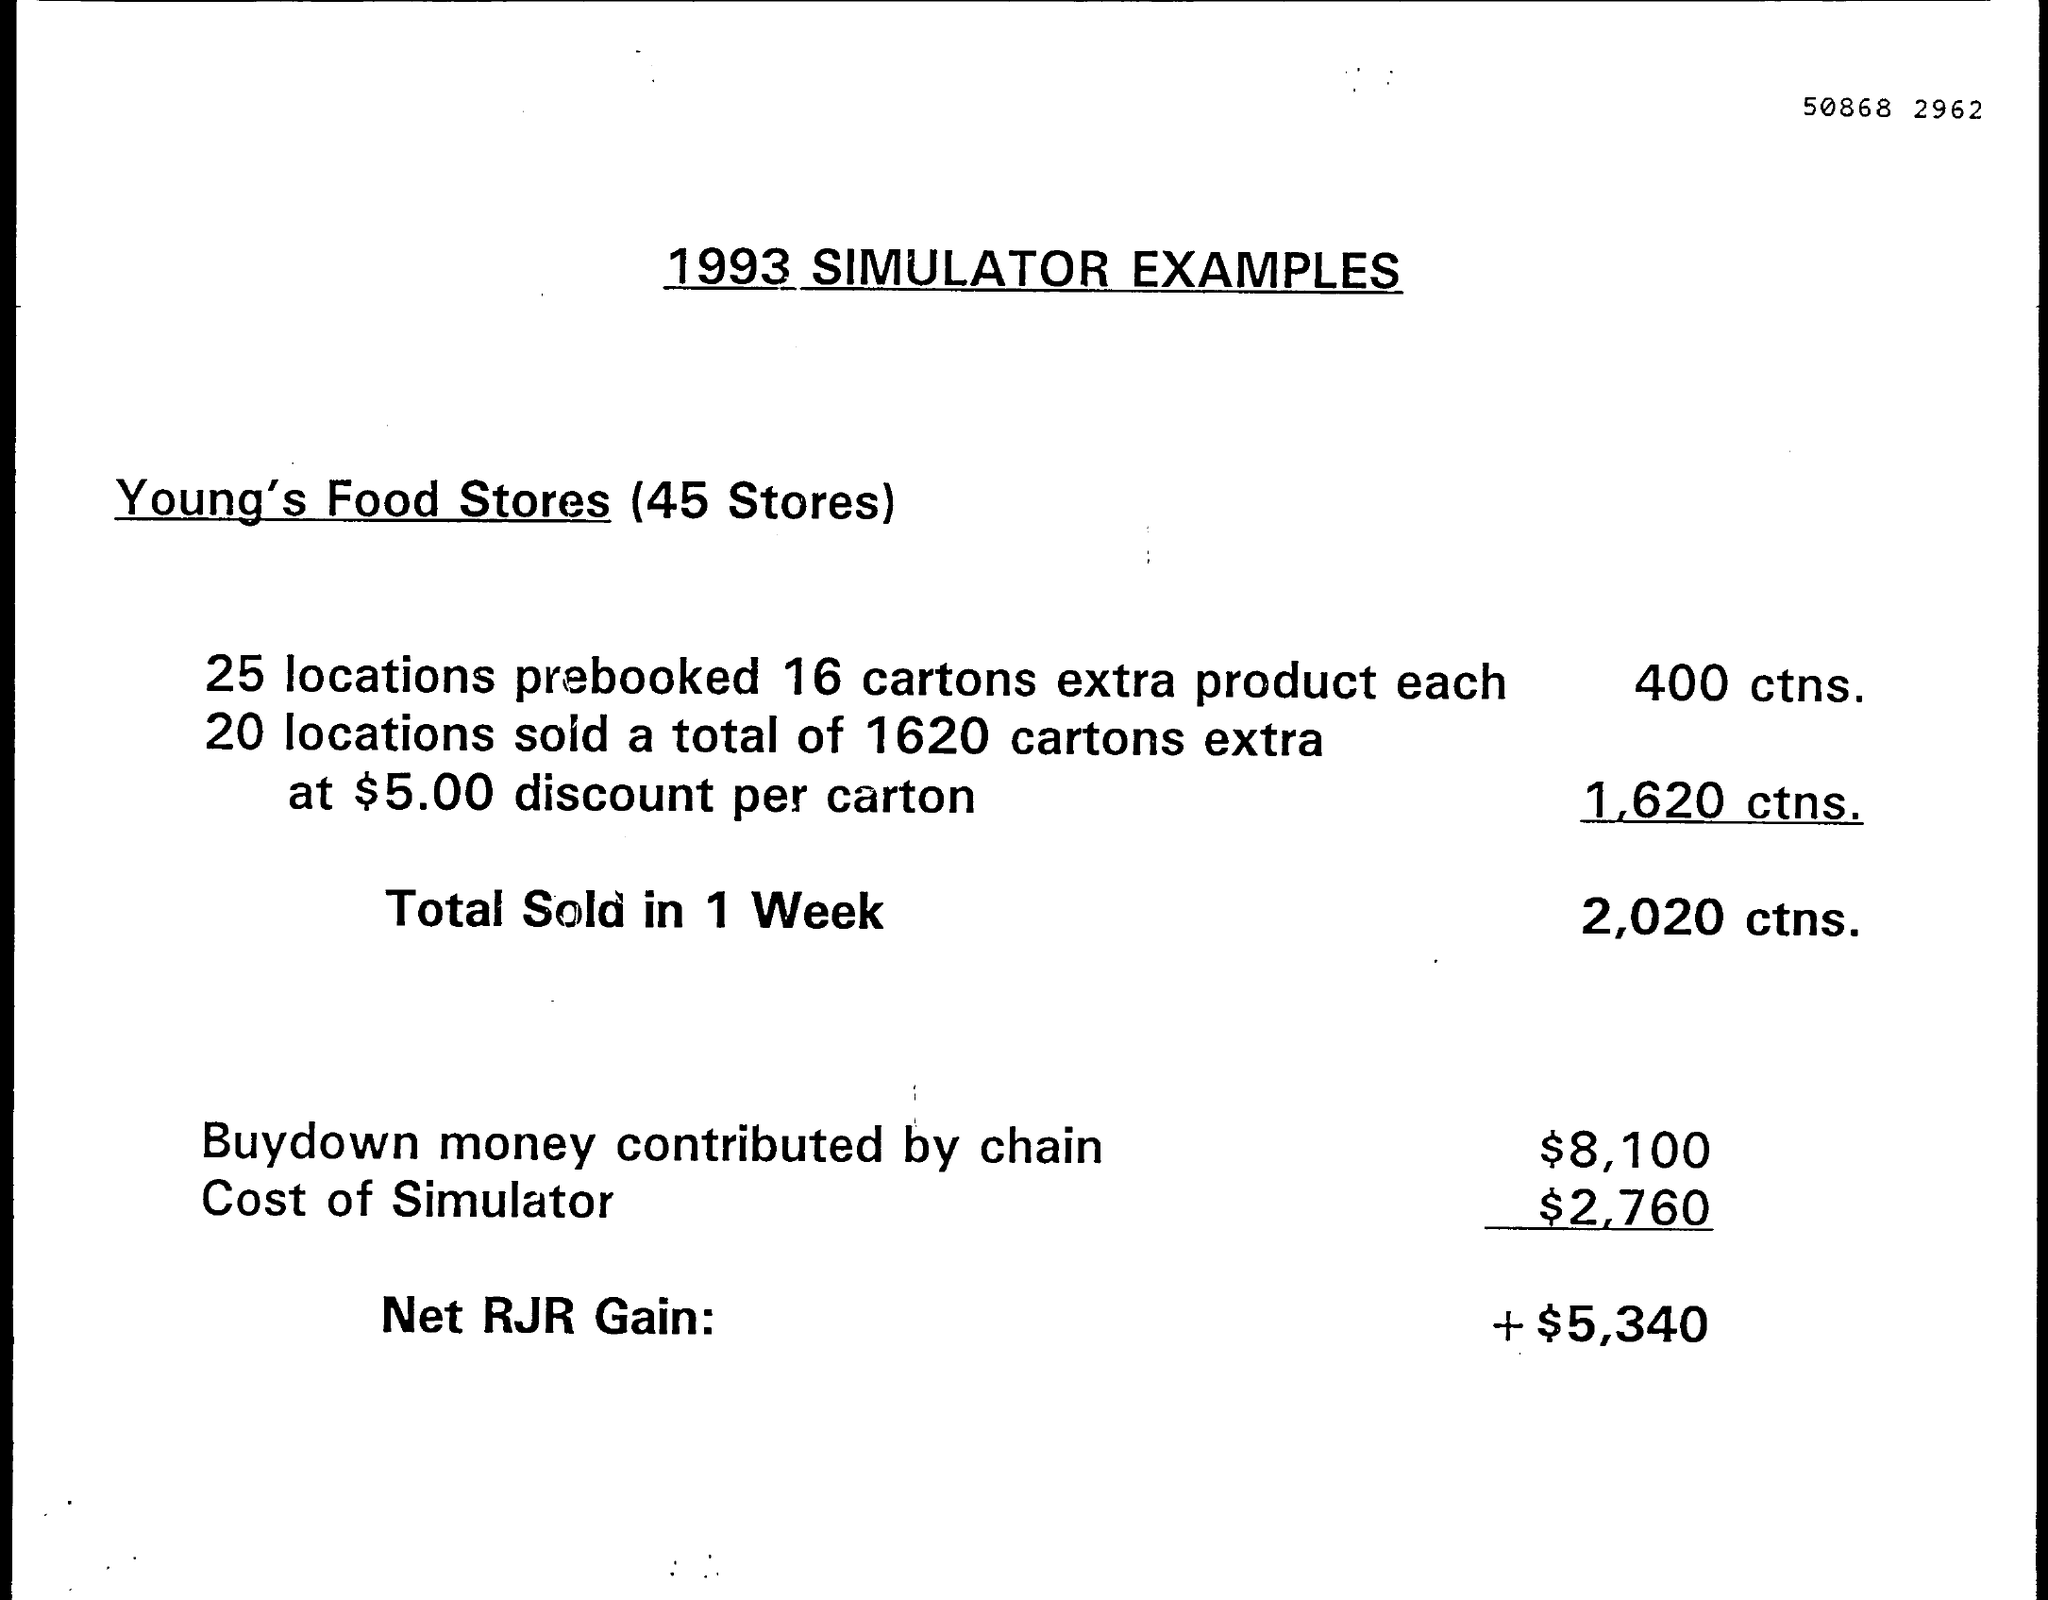What is the total number of cartons sold in 1 week?
Your answer should be very brief. 2,020. How many stores does Young's food stores have?
Offer a very short reply. 45 stores. 